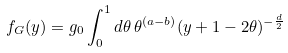<formula> <loc_0><loc_0><loc_500><loc_500>f _ { G } ( y ) = g _ { 0 } \int _ { 0 } ^ { 1 } d \theta \, \theta ^ { ( a - b ) } ( y + 1 - 2 \theta ) ^ { - \frac { d } { 2 } }</formula> 